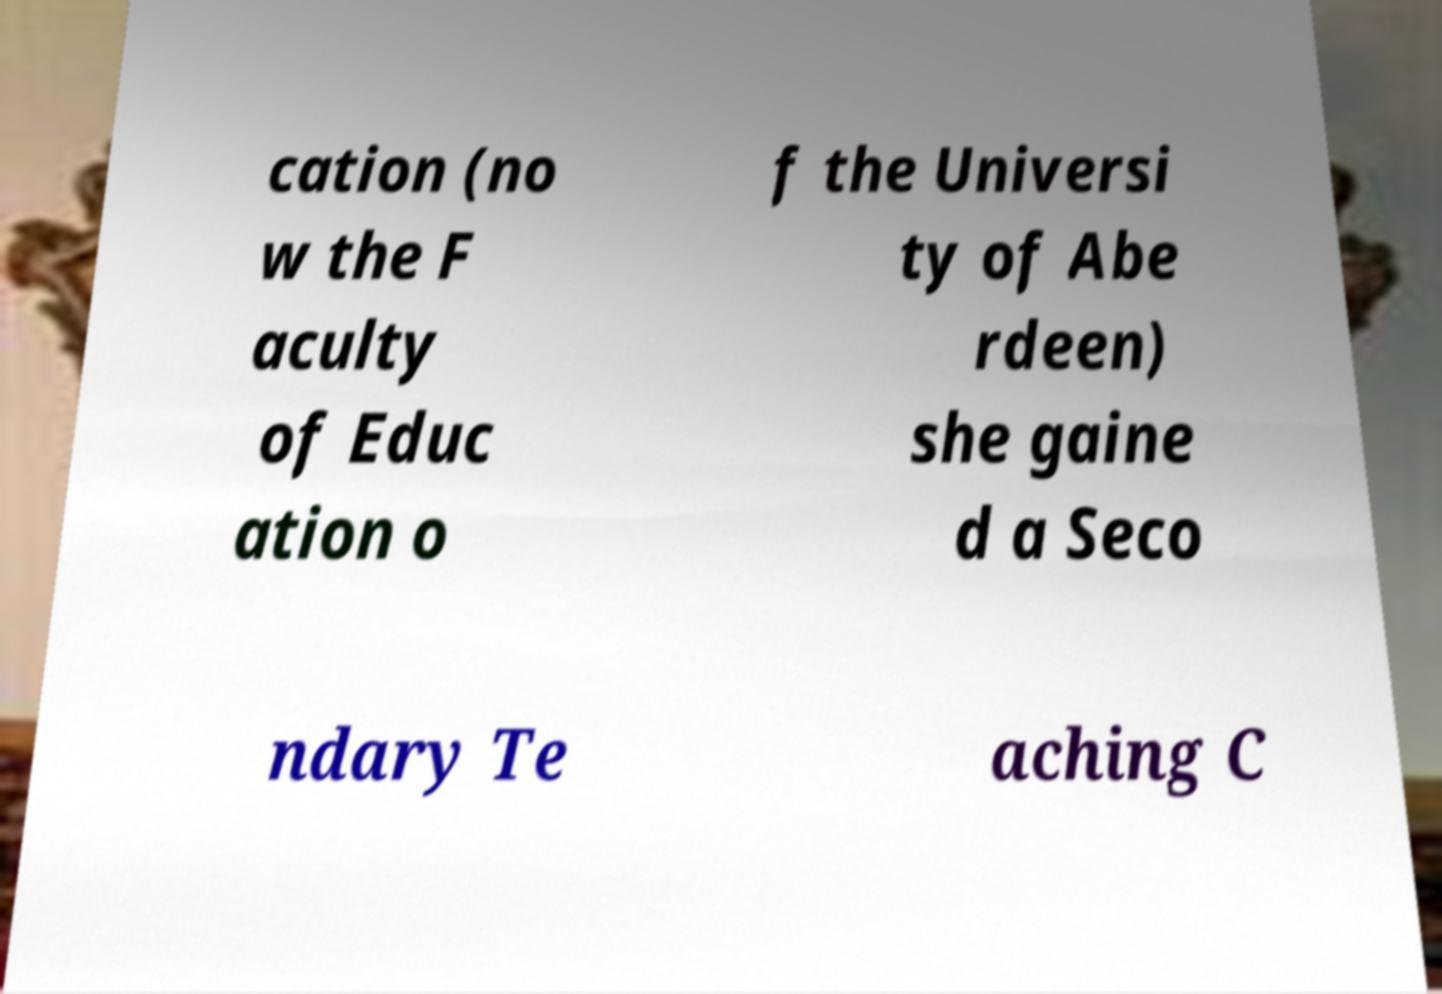There's text embedded in this image that I need extracted. Can you transcribe it verbatim? cation (no w the F aculty of Educ ation o f the Universi ty of Abe rdeen) she gaine d a Seco ndary Te aching C 